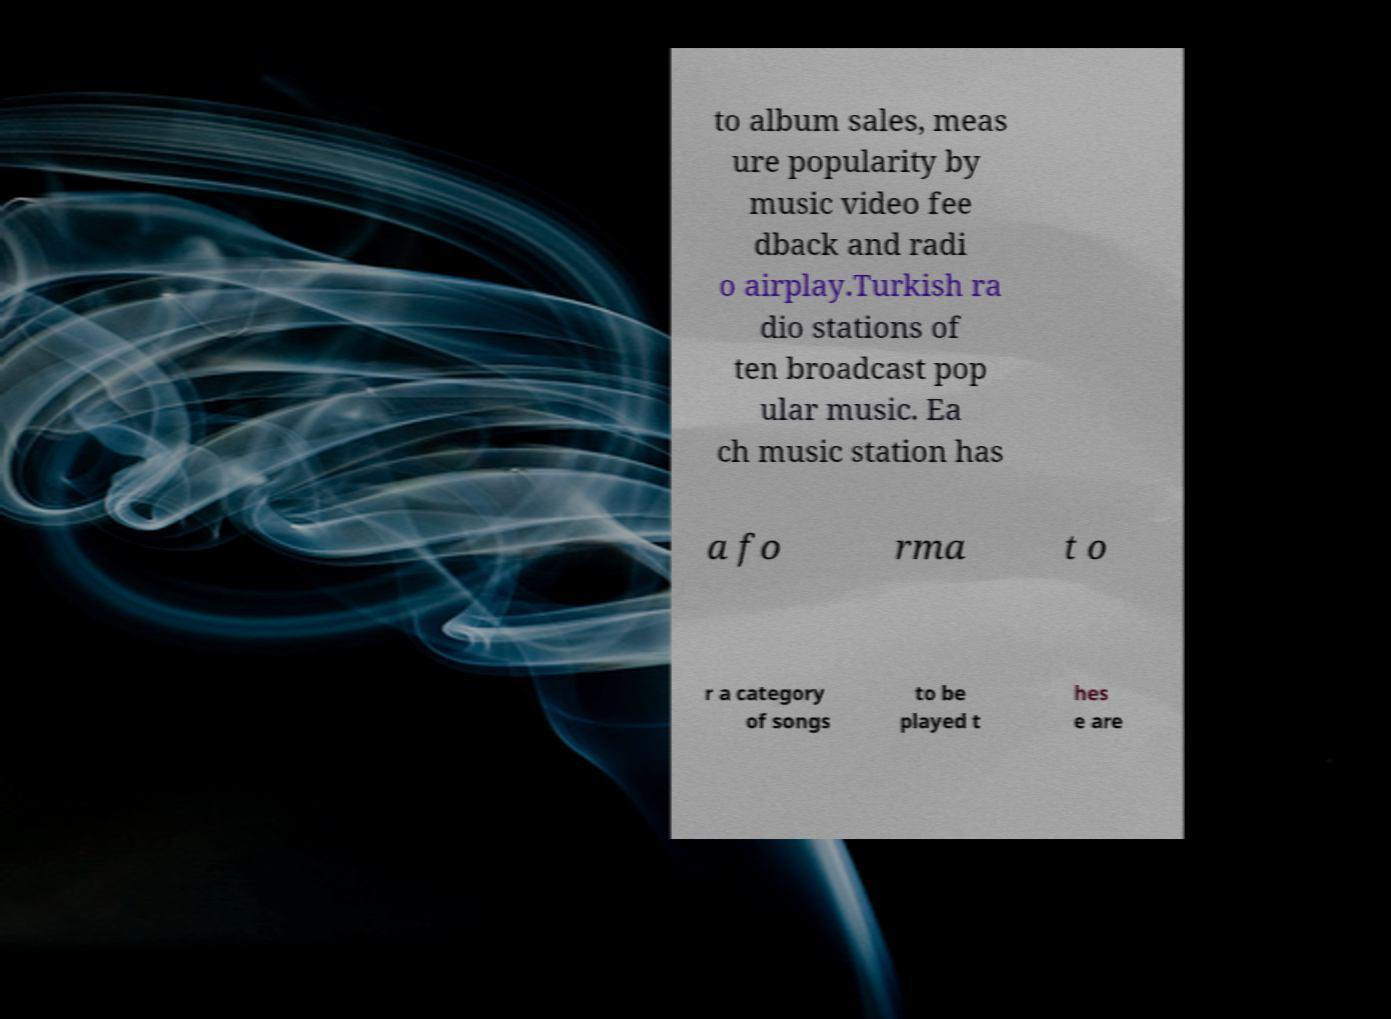There's text embedded in this image that I need extracted. Can you transcribe it verbatim? to album sales, meas ure popularity by music video fee dback and radi o airplay.Turkish ra dio stations of ten broadcast pop ular music. Ea ch music station has a fo rma t o r a category of songs to be played t hes e are 